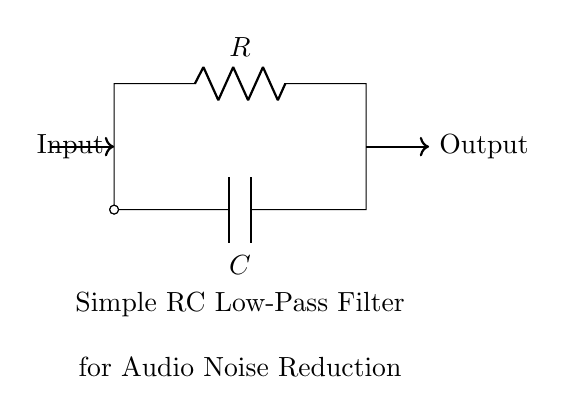What components are in this circuit? The circuit consists of a resistor and a capacitor. These components are labeled R and C in the diagram.
Answer: Resistor and capacitor What is the purpose of this circuit? The purpose is to reduce noise in audio equipment. This is indicated in the text below the circuit diagram.
Answer: Noise reduction What type of filter is represented by this circuit? This circuit is a low-pass filter, as indicated by its design to allow low-frequency signals to pass while attenuating higher frequencies.
Answer: Low-pass filter How many terminals does the capacitor have? The capacitor has two terminals, as seen in the circuit where the capacitor leads connect to the circuit at two distinct points.
Answer: Two What happens to high-frequency signals in this circuit? High-frequency signals are attenuated, meaning their amplitude is reduced as they pass through the circuit. This is the fundamental operation of a low-pass filter.
Answer: Attenuated What is the input of the circuit? The input is indicated by the arrow labeled at the left side of the circuit, which shows where the signal enters the circuit.
Answer: Input signal What does the output of the circuit represent? The output is the processed signal that appears at the right side of the circuit after passing through the RC components, specifically the filtered audio signal.
Answer: Output signal 